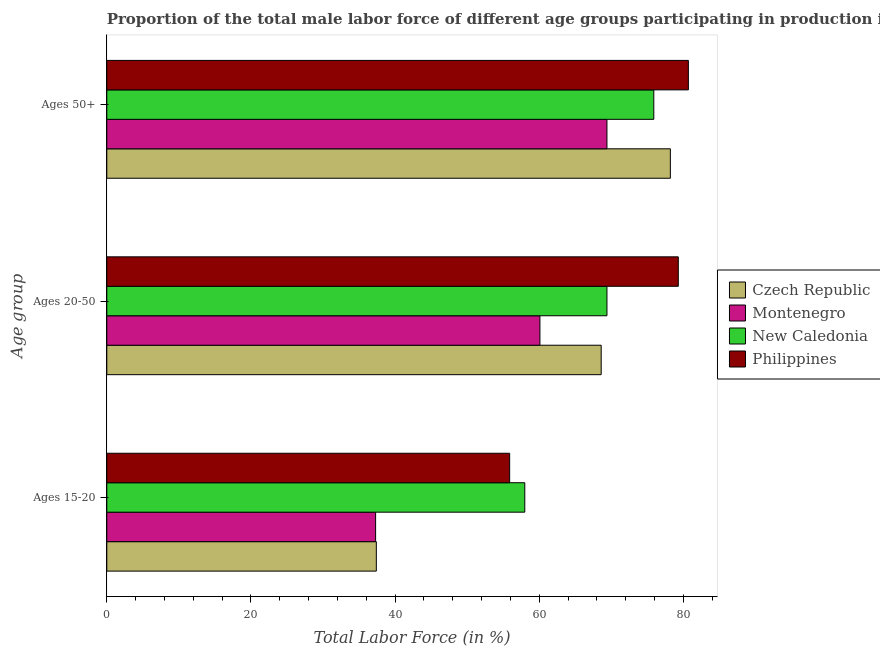Are the number of bars per tick equal to the number of legend labels?
Provide a succinct answer. Yes. Are the number of bars on each tick of the Y-axis equal?
Keep it short and to the point. Yes. How many bars are there on the 2nd tick from the bottom?
Provide a succinct answer. 4. What is the label of the 2nd group of bars from the top?
Keep it short and to the point. Ages 20-50. What is the percentage of male labor force above age 50 in Czech Republic?
Your answer should be compact. 78.2. Across all countries, what is the minimum percentage of male labor force above age 50?
Give a very brief answer. 69.4. In which country was the percentage of male labor force within the age group 20-50 maximum?
Offer a very short reply. Philippines. In which country was the percentage of male labor force within the age group 20-50 minimum?
Give a very brief answer. Montenegro. What is the total percentage of male labor force within the age group 20-50 in the graph?
Make the answer very short. 277.4. What is the difference between the percentage of male labor force above age 50 in New Caledonia and that in Montenegro?
Provide a short and direct response. 6.5. What is the difference between the percentage of male labor force above age 50 in Czech Republic and the percentage of male labor force within the age group 15-20 in New Caledonia?
Your answer should be compact. 20.2. What is the average percentage of male labor force within the age group 15-20 per country?
Make the answer very short. 47.15. What is the difference between the percentage of male labor force within the age group 20-50 and percentage of male labor force within the age group 15-20 in Montenegro?
Your answer should be very brief. 22.8. What is the ratio of the percentage of male labor force within the age group 20-50 in Montenegro to that in Philippines?
Provide a succinct answer. 0.76. Is the percentage of male labor force within the age group 20-50 in Czech Republic less than that in New Caledonia?
Make the answer very short. Yes. Is the difference between the percentage of male labor force within the age group 15-20 in Montenegro and Philippines greater than the difference between the percentage of male labor force within the age group 20-50 in Montenegro and Philippines?
Give a very brief answer. Yes. What is the difference between the highest and the second highest percentage of male labor force within the age group 15-20?
Offer a very short reply. 2.1. What is the difference between the highest and the lowest percentage of male labor force within the age group 20-50?
Your response must be concise. 19.2. In how many countries, is the percentage of male labor force within the age group 15-20 greater than the average percentage of male labor force within the age group 15-20 taken over all countries?
Ensure brevity in your answer.  2. Is the sum of the percentage of male labor force within the age group 15-20 in New Caledonia and Czech Republic greater than the maximum percentage of male labor force above age 50 across all countries?
Your answer should be compact. Yes. What does the 4th bar from the top in Ages 15-20 represents?
Provide a short and direct response. Czech Republic. What does the 2nd bar from the bottom in Ages 20-50 represents?
Keep it short and to the point. Montenegro. Is it the case that in every country, the sum of the percentage of male labor force within the age group 15-20 and percentage of male labor force within the age group 20-50 is greater than the percentage of male labor force above age 50?
Provide a succinct answer. Yes. How many bars are there?
Give a very brief answer. 12. Are all the bars in the graph horizontal?
Make the answer very short. Yes. Does the graph contain grids?
Provide a short and direct response. No. Where does the legend appear in the graph?
Ensure brevity in your answer.  Center right. How many legend labels are there?
Your answer should be very brief. 4. What is the title of the graph?
Your answer should be very brief. Proportion of the total male labor force of different age groups participating in production in 2006. Does "Bahrain" appear as one of the legend labels in the graph?
Provide a short and direct response. No. What is the label or title of the X-axis?
Make the answer very short. Total Labor Force (in %). What is the label or title of the Y-axis?
Give a very brief answer. Age group. What is the Total Labor Force (in %) of Czech Republic in Ages 15-20?
Provide a short and direct response. 37.4. What is the Total Labor Force (in %) in Montenegro in Ages 15-20?
Offer a very short reply. 37.3. What is the Total Labor Force (in %) of New Caledonia in Ages 15-20?
Keep it short and to the point. 58. What is the Total Labor Force (in %) in Philippines in Ages 15-20?
Provide a succinct answer. 55.9. What is the Total Labor Force (in %) in Czech Republic in Ages 20-50?
Your answer should be compact. 68.6. What is the Total Labor Force (in %) in Montenegro in Ages 20-50?
Provide a succinct answer. 60.1. What is the Total Labor Force (in %) of New Caledonia in Ages 20-50?
Your response must be concise. 69.4. What is the Total Labor Force (in %) in Philippines in Ages 20-50?
Your answer should be very brief. 79.3. What is the Total Labor Force (in %) in Czech Republic in Ages 50+?
Give a very brief answer. 78.2. What is the Total Labor Force (in %) in Montenegro in Ages 50+?
Ensure brevity in your answer.  69.4. What is the Total Labor Force (in %) of New Caledonia in Ages 50+?
Offer a terse response. 75.9. What is the Total Labor Force (in %) in Philippines in Ages 50+?
Provide a short and direct response. 80.7. Across all Age group, what is the maximum Total Labor Force (in %) of Czech Republic?
Offer a very short reply. 78.2. Across all Age group, what is the maximum Total Labor Force (in %) in Montenegro?
Provide a short and direct response. 69.4. Across all Age group, what is the maximum Total Labor Force (in %) of New Caledonia?
Your answer should be compact. 75.9. Across all Age group, what is the maximum Total Labor Force (in %) in Philippines?
Your answer should be very brief. 80.7. Across all Age group, what is the minimum Total Labor Force (in %) in Czech Republic?
Provide a short and direct response. 37.4. Across all Age group, what is the minimum Total Labor Force (in %) in Montenegro?
Make the answer very short. 37.3. Across all Age group, what is the minimum Total Labor Force (in %) in Philippines?
Ensure brevity in your answer.  55.9. What is the total Total Labor Force (in %) of Czech Republic in the graph?
Provide a short and direct response. 184.2. What is the total Total Labor Force (in %) in Montenegro in the graph?
Ensure brevity in your answer.  166.8. What is the total Total Labor Force (in %) in New Caledonia in the graph?
Offer a terse response. 203.3. What is the total Total Labor Force (in %) of Philippines in the graph?
Make the answer very short. 215.9. What is the difference between the Total Labor Force (in %) of Czech Republic in Ages 15-20 and that in Ages 20-50?
Offer a terse response. -31.2. What is the difference between the Total Labor Force (in %) of Montenegro in Ages 15-20 and that in Ages 20-50?
Your answer should be very brief. -22.8. What is the difference between the Total Labor Force (in %) of Philippines in Ages 15-20 and that in Ages 20-50?
Offer a very short reply. -23.4. What is the difference between the Total Labor Force (in %) in Czech Republic in Ages 15-20 and that in Ages 50+?
Make the answer very short. -40.8. What is the difference between the Total Labor Force (in %) in Montenegro in Ages 15-20 and that in Ages 50+?
Give a very brief answer. -32.1. What is the difference between the Total Labor Force (in %) of New Caledonia in Ages 15-20 and that in Ages 50+?
Give a very brief answer. -17.9. What is the difference between the Total Labor Force (in %) of Philippines in Ages 15-20 and that in Ages 50+?
Offer a very short reply. -24.8. What is the difference between the Total Labor Force (in %) in Philippines in Ages 20-50 and that in Ages 50+?
Your answer should be compact. -1.4. What is the difference between the Total Labor Force (in %) of Czech Republic in Ages 15-20 and the Total Labor Force (in %) of Montenegro in Ages 20-50?
Offer a terse response. -22.7. What is the difference between the Total Labor Force (in %) of Czech Republic in Ages 15-20 and the Total Labor Force (in %) of New Caledonia in Ages 20-50?
Provide a short and direct response. -32. What is the difference between the Total Labor Force (in %) in Czech Republic in Ages 15-20 and the Total Labor Force (in %) in Philippines in Ages 20-50?
Ensure brevity in your answer.  -41.9. What is the difference between the Total Labor Force (in %) of Montenegro in Ages 15-20 and the Total Labor Force (in %) of New Caledonia in Ages 20-50?
Your answer should be compact. -32.1. What is the difference between the Total Labor Force (in %) in Montenegro in Ages 15-20 and the Total Labor Force (in %) in Philippines in Ages 20-50?
Provide a succinct answer. -42. What is the difference between the Total Labor Force (in %) of New Caledonia in Ages 15-20 and the Total Labor Force (in %) of Philippines in Ages 20-50?
Offer a terse response. -21.3. What is the difference between the Total Labor Force (in %) in Czech Republic in Ages 15-20 and the Total Labor Force (in %) in Montenegro in Ages 50+?
Provide a succinct answer. -32. What is the difference between the Total Labor Force (in %) of Czech Republic in Ages 15-20 and the Total Labor Force (in %) of New Caledonia in Ages 50+?
Offer a terse response. -38.5. What is the difference between the Total Labor Force (in %) in Czech Republic in Ages 15-20 and the Total Labor Force (in %) in Philippines in Ages 50+?
Offer a very short reply. -43.3. What is the difference between the Total Labor Force (in %) of Montenegro in Ages 15-20 and the Total Labor Force (in %) of New Caledonia in Ages 50+?
Ensure brevity in your answer.  -38.6. What is the difference between the Total Labor Force (in %) of Montenegro in Ages 15-20 and the Total Labor Force (in %) of Philippines in Ages 50+?
Your response must be concise. -43.4. What is the difference between the Total Labor Force (in %) in New Caledonia in Ages 15-20 and the Total Labor Force (in %) in Philippines in Ages 50+?
Give a very brief answer. -22.7. What is the difference between the Total Labor Force (in %) of Czech Republic in Ages 20-50 and the Total Labor Force (in %) of Montenegro in Ages 50+?
Offer a very short reply. -0.8. What is the difference between the Total Labor Force (in %) in Czech Republic in Ages 20-50 and the Total Labor Force (in %) in Philippines in Ages 50+?
Your answer should be very brief. -12.1. What is the difference between the Total Labor Force (in %) of Montenegro in Ages 20-50 and the Total Labor Force (in %) of New Caledonia in Ages 50+?
Offer a very short reply. -15.8. What is the difference between the Total Labor Force (in %) of Montenegro in Ages 20-50 and the Total Labor Force (in %) of Philippines in Ages 50+?
Provide a short and direct response. -20.6. What is the average Total Labor Force (in %) in Czech Republic per Age group?
Give a very brief answer. 61.4. What is the average Total Labor Force (in %) of Montenegro per Age group?
Your answer should be very brief. 55.6. What is the average Total Labor Force (in %) of New Caledonia per Age group?
Provide a short and direct response. 67.77. What is the average Total Labor Force (in %) of Philippines per Age group?
Provide a succinct answer. 71.97. What is the difference between the Total Labor Force (in %) of Czech Republic and Total Labor Force (in %) of Montenegro in Ages 15-20?
Keep it short and to the point. 0.1. What is the difference between the Total Labor Force (in %) of Czech Republic and Total Labor Force (in %) of New Caledonia in Ages 15-20?
Provide a short and direct response. -20.6. What is the difference between the Total Labor Force (in %) of Czech Republic and Total Labor Force (in %) of Philippines in Ages 15-20?
Your answer should be compact. -18.5. What is the difference between the Total Labor Force (in %) of Montenegro and Total Labor Force (in %) of New Caledonia in Ages 15-20?
Provide a short and direct response. -20.7. What is the difference between the Total Labor Force (in %) of Montenegro and Total Labor Force (in %) of Philippines in Ages 15-20?
Your answer should be very brief. -18.6. What is the difference between the Total Labor Force (in %) of New Caledonia and Total Labor Force (in %) of Philippines in Ages 15-20?
Provide a succinct answer. 2.1. What is the difference between the Total Labor Force (in %) in Czech Republic and Total Labor Force (in %) in Montenegro in Ages 20-50?
Your response must be concise. 8.5. What is the difference between the Total Labor Force (in %) in Czech Republic and Total Labor Force (in %) in Philippines in Ages 20-50?
Your answer should be very brief. -10.7. What is the difference between the Total Labor Force (in %) in Montenegro and Total Labor Force (in %) in Philippines in Ages 20-50?
Your response must be concise. -19.2. What is the difference between the Total Labor Force (in %) in Czech Republic and Total Labor Force (in %) in Montenegro in Ages 50+?
Offer a very short reply. 8.8. What is the difference between the Total Labor Force (in %) of Czech Republic and Total Labor Force (in %) of Philippines in Ages 50+?
Give a very brief answer. -2.5. What is the difference between the Total Labor Force (in %) in Montenegro and Total Labor Force (in %) in New Caledonia in Ages 50+?
Give a very brief answer. -6.5. What is the difference between the Total Labor Force (in %) of New Caledonia and Total Labor Force (in %) of Philippines in Ages 50+?
Offer a very short reply. -4.8. What is the ratio of the Total Labor Force (in %) of Czech Republic in Ages 15-20 to that in Ages 20-50?
Offer a terse response. 0.55. What is the ratio of the Total Labor Force (in %) of Montenegro in Ages 15-20 to that in Ages 20-50?
Make the answer very short. 0.62. What is the ratio of the Total Labor Force (in %) in New Caledonia in Ages 15-20 to that in Ages 20-50?
Provide a short and direct response. 0.84. What is the ratio of the Total Labor Force (in %) in Philippines in Ages 15-20 to that in Ages 20-50?
Offer a very short reply. 0.7. What is the ratio of the Total Labor Force (in %) in Czech Republic in Ages 15-20 to that in Ages 50+?
Your response must be concise. 0.48. What is the ratio of the Total Labor Force (in %) in Montenegro in Ages 15-20 to that in Ages 50+?
Offer a very short reply. 0.54. What is the ratio of the Total Labor Force (in %) in New Caledonia in Ages 15-20 to that in Ages 50+?
Provide a succinct answer. 0.76. What is the ratio of the Total Labor Force (in %) of Philippines in Ages 15-20 to that in Ages 50+?
Provide a succinct answer. 0.69. What is the ratio of the Total Labor Force (in %) in Czech Republic in Ages 20-50 to that in Ages 50+?
Your answer should be compact. 0.88. What is the ratio of the Total Labor Force (in %) of Montenegro in Ages 20-50 to that in Ages 50+?
Provide a short and direct response. 0.87. What is the ratio of the Total Labor Force (in %) in New Caledonia in Ages 20-50 to that in Ages 50+?
Give a very brief answer. 0.91. What is the ratio of the Total Labor Force (in %) of Philippines in Ages 20-50 to that in Ages 50+?
Provide a short and direct response. 0.98. What is the difference between the highest and the second highest Total Labor Force (in %) of Montenegro?
Ensure brevity in your answer.  9.3. What is the difference between the highest and the second highest Total Labor Force (in %) in Philippines?
Offer a terse response. 1.4. What is the difference between the highest and the lowest Total Labor Force (in %) of Czech Republic?
Offer a terse response. 40.8. What is the difference between the highest and the lowest Total Labor Force (in %) in Montenegro?
Your answer should be very brief. 32.1. What is the difference between the highest and the lowest Total Labor Force (in %) of New Caledonia?
Provide a short and direct response. 17.9. What is the difference between the highest and the lowest Total Labor Force (in %) in Philippines?
Ensure brevity in your answer.  24.8. 